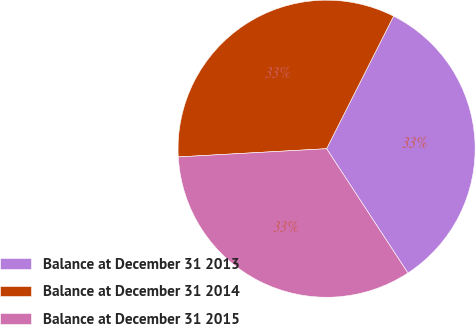Convert chart to OTSL. <chart><loc_0><loc_0><loc_500><loc_500><pie_chart><fcel>Balance at December 31 2013<fcel>Balance at December 31 2014<fcel>Balance at December 31 2015<nl><fcel>33.33%<fcel>33.33%<fcel>33.34%<nl></chart> 